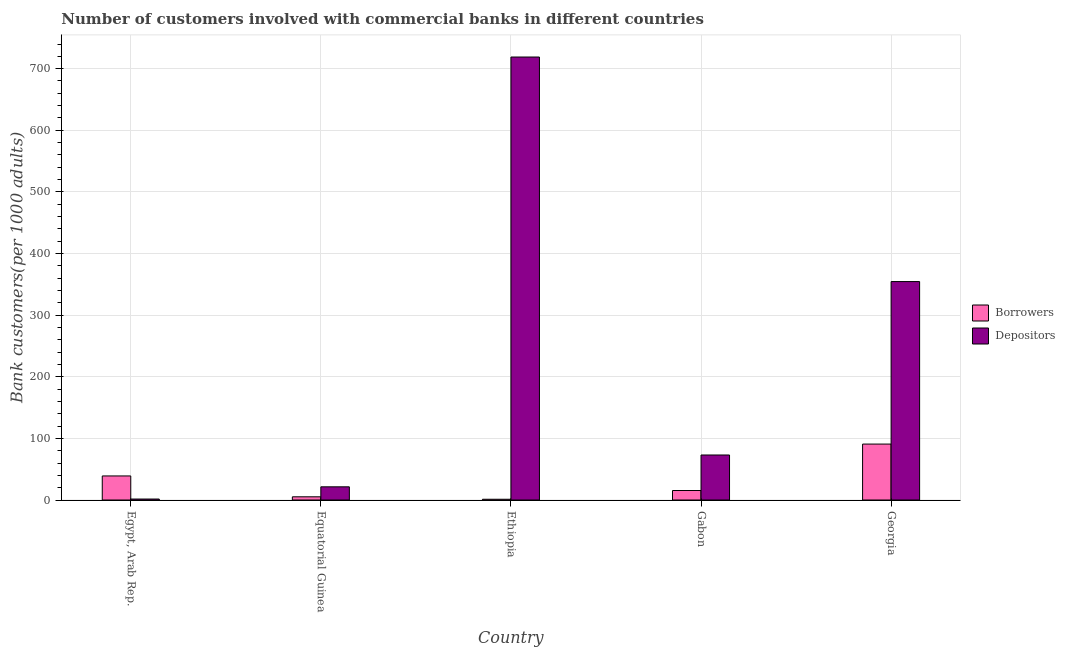How many different coloured bars are there?
Offer a very short reply. 2. How many groups of bars are there?
Your answer should be compact. 5. Are the number of bars per tick equal to the number of legend labels?
Ensure brevity in your answer.  Yes. Are the number of bars on each tick of the X-axis equal?
Make the answer very short. Yes. How many bars are there on the 3rd tick from the left?
Provide a succinct answer. 2. What is the label of the 2nd group of bars from the left?
Keep it short and to the point. Equatorial Guinea. In how many cases, is the number of bars for a given country not equal to the number of legend labels?
Your response must be concise. 0. What is the number of borrowers in Equatorial Guinea?
Offer a very short reply. 5.18. Across all countries, what is the maximum number of depositors?
Offer a very short reply. 718.87. Across all countries, what is the minimum number of depositors?
Make the answer very short. 1.56. In which country was the number of borrowers maximum?
Provide a succinct answer. Georgia. In which country was the number of borrowers minimum?
Provide a short and direct response. Ethiopia. What is the total number of borrowers in the graph?
Ensure brevity in your answer.  151.61. What is the difference between the number of borrowers in Equatorial Guinea and that in Ethiopia?
Make the answer very short. 3.97. What is the difference between the number of depositors in Georgia and the number of borrowers in Egypt, Arab Rep.?
Ensure brevity in your answer.  315.41. What is the average number of depositors per country?
Offer a terse response. 233.86. What is the difference between the number of depositors and number of borrowers in Georgia?
Your answer should be very brief. 263.68. What is the ratio of the number of borrowers in Equatorial Guinea to that in Gabon?
Your answer should be compact. 0.34. Is the number of depositors in Ethiopia less than that in Gabon?
Your answer should be very brief. No. What is the difference between the highest and the second highest number of depositors?
Offer a very short reply. 364.4. What is the difference between the highest and the lowest number of borrowers?
Keep it short and to the point. 89.57. In how many countries, is the number of depositors greater than the average number of depositors taken over all countries?
Provide a short and direct response. 2. What does the 1st bar from the left in Gabon represents?
Keep it short and to the point. Borrowers. What does the 2nd bar from the right in Georgia represents?
Give a very brief answer. Borrowers. How many countries are there in the graph?
Keep it short and to the point. 5. Does the graph contain grids?
Your response must be concise. Yes. Where does the legend appear in the graph?
Your answer should be very brief. Center right. How many legend labels are there?
Offer a terse response. 2. How are the legend labels stacked?
Your answer should be very brief. Vertical. What is the title of the graph?
Give a very brief answer. Number of customers involved with commercial banks in different countries. What is the label or title of the Y-axis?
Offer a very short reply. Bank customers(per 1000 adults). What is the Bank customers(per 1000 adults) in Borrowers in Egypt, Arab Rep.?
Keep it short and to the point. 39.05. What is the Bank customers(per 1000 adults) in Depositors in Egypt, Arab Rep.?
Offer a terse response. 1.56. What is the Bank customers(per 1000 adults) of Borrowers in Equatorial Guinea?
Keep it short and to the point. 5.18. What is the Bank customers(per 1000 adults) of Depositors in Equatorial Guinea?
Give a very brief answer. 21.4. What is the Bank customers(per 1000 adults) of Borrowers in Ethiopia?
Make the answer very short. 1.21. What is the Bank customers(per 1000 adults) of Depositors in Ethiopia?
Keep it short and to the point. 718.87. What is the Bank customers(per 1000 adults) in Borrowers in Gabon?
Offer a terse response. 15.4. What is the Bank customers(per 1000 adults) of Depositors in Gabon?
Your response must be concise. 73.03. What is the Bank customers(per 1000 adults) of Borrowers in Georgia?
Your answer should be very brief. 90.78. What is the Bank customers(per 1000 adults) in Depositors in Georgia?
Offer a very short reply. 354.46. Across all countries, what is the maximum Bank customers(per 1000 adults) of Borrowers?
Keep it short and to the point. 90.78. Across all countries, what is the maximum Bank customers(per 1000 adults) in Depositors?
Make the answer very short. 718.87. Across all countries, what is the minimum Bank customers(per 1000 adults) in Borrowers?
Provide a succinct answer. 1.21. Across all countries, what is the minimum Bank customers(per 1000 adults) of Depositors?
Make the answer very short. 1.56. What is the total Bank customers(per 1000 adults) in Borrowers in the graph?
Your answer should be compact. 151.61. What is the total Bank customers(per 1000 adults) of Depositors in the graph?
Ensure brevity in your answer.  1169.32. What is the difference between the Bank customers(per 1000 adults) of Borrowers in Egypt, Arab Rep. and that in Equatorial Guinea?
Your answer should be compact. 33.87. What is the difference between the Bank customers(per 1000 adults) in Depositors in Egypt, Arab Rep. and that in Equatorial Guinea?
Ensure brevity in your answer.  -19.83. What is the difference between the Bank customers(per 1000 adults) of Borrowers in Egypt, Arab Rep. and that in Ethiopia?
Offer a very short reply. 37.84. What is the difference between the Bank customers(per 1000 adults) in Depositors in Egypt, Arab Rep. and that in Ethiopia?
Ensure brevity in your answer.  -717.3. What is the difference between the Bank customers(per 1000 adults) of Borrowers in Egypt, Arab Rep. and that in Gabon?
Keep it short and to the point. 23.65. What is the difference between the Bank customers(per 1000 adults) of Depositors in Egypt, Arab Rep. and that in Gabon?
Offer a terse response. -71.47. What is the difference between the Bank customers(per 1000 adults) of Borrowers in Egypt, Arab Rep. and that in Georgia?
Your answer should be very brief. -51.73. What is the difference between the Bank customers(per 1000 adults) of Depositors in Egypt, Arab Rep. and that in Georgia?
Your response must be concise. -352.9. What is the difference between the Bank customers(per 1000 adults) in Borrowers in Equatorial Guinea and that in Ethiopia?
Make the answer very short. 3.97. What is the difference between the Bank customers(per 1000 adults) of Depositors in Equatorial Guinea and that in Ethiopia?
Your answer should be very brief. -697.47. What is the difference between the Bank customers(per 1000 adults) of Borrowers in Equatorial Guinea and that in Gabon?
Ensure brevity in your answer.  -10.22. What is the difference between the Bank customers(per 1000 adults) of Depositors in Equatorial Guinea and that in Gabon?
Give a very brief answer. -51.64. What is the difference between the Bank customers(per 1000 adults) of Borrowers in Equatorial Guinea and that in Georgia?
Offer a very short reply. -85.6. What is the difference between the Bank customers(per 1000 adults) in Depositors in Equatorial Guinea and that in Georgia?
Provide a succinct answer. -333.07. What is the difference between the Bank customers(per 1000 adults) of Borrowers in Ethiopia and that in Gabon?
Provide a succinct answer. -14.2. What is the difference between the Bank customers(per 1000 adults) of Depositors in Ethiopia and that in Gabon?
Your response must be concise. 645.83. What is the difference between the Bank customers(per 1000 adults) of Borrowers in Ethiopia and that in Georgia?
Give a very brief answer. -89.57. What is the difference between the Bank customers(per 1000 adults) of Depositors in Ethiopia and that in Georgia?
Your response must be concise. 364.4. What is the difference between the Bank customers(per 1000 adults) in Borrowers in Gabon and that in Georgia?
Ensure brevity in your answer.  -75.38. What is the difference between the Bank customers(per 1000 adults) of Depositors in Gabon and that in Georgia?
Keep it short and to the point. -281.43. What is the difference between the Bank customers(per 1000 adults) in Borrowers in Egypt, Arab Rep. and the Bank customers(per 1000 adults) in Depositors in Equatorial Guinea?
Your answer should be very brief. 17.65. What is the difference between the Bank customers(per 1000 adults) in Borrowers in Egypt, Arab Rep. and the Bank customers(per 1000 adults) in Depositors in Ethiopia?
Make the answer very short. -679.82. What is the difference between the Bank customers(per 1000 adults) in Borrowers in Egypt, Arab Rep. and the Bank customers(per 1000 adults) in Depositors in Gabon?
Keep it short and to the point. -33.98. What is the difference between the Bank customers(per 1000 adults) of Borrowers in Egypt, Arab Rep. and the Bank customers(per 1000 adults) of Depositors in Georgia?
Your answer should be very brief. -315.41. What is the difference between the Bank customers(per 1000 adults) in Borrowers in Equatorial Guinea and the Bank customers(per 1000 adults) in Depositors in Ethiopia?
Give a very brief answer. -713.69. What is the difference between the Bank customers(per 1000 adults) of Borrowers in Equatorial Guinea and the Bank customers(per 1000 adults) of Depositors in Gabon?
Make the answer very short. -67.85. What is the difference between the Bank customers(per 1000 adults) in Borrowers in Equatorial Guinea and the Bank customers(per 1000 adults) in Depositors in Georgia?
Keep it short and to the point. -349.29. What is the difference between the Bank customers(per 1000 adults) of Borrowers in Ethiopia and the Bank customers(per 1000 adults) of Depositors in Gabon?
Offer a terse response. -71.83. What is the difference between the Bank customers(per 1000 adults) of Borrowers in Ethiopia and the Bank customers(per 1000 adults) of Depositors in Georgia?
Keep it short and to the point. -353.26. What is the difference between the Bank customers(per 1000 adults) in Borrowers in Gabon and the Bank customers(per 1000 adults) in Depositors in Georgia?
Make the answer very short. -339.06. What is the average Bank customers(per 1000 adults) in Borrowers per country?
Offer a terse response. 30.32. What is the average Bank customers(per 1000 adults) in Depositors per country?
Your answer should be compact. 233.86. What is the difference between the Bank customers(per 1000 adults) in Borrowers and Bank customers(per 1000 adults) in Depositors in Egypt, Arab Rep.?
Your answer should be compact. 37.49. What is the difference between the Bank customers(per 1000 adults) of Borrowers and Bank customers(per 1000 adults) of Depositors in Equatorial Guinea?
Your response must be concise. -16.22. What is the difference between the Bank customers(per 1000 adults) of Borrowers and Bank customers(per 1000 adults) of Depositors in Ethiopia?
Provide a succinct answer. -717.66. What is the difference between the Bank customers(per 1000 adults) of Borrowers and Bank customers(per 1000 adults) of Depositors in Gabon?
Your answer should be compact. -57.63. What is the difference between the Bank customers(per 1000 adults) of Borrowers and Bank customers(per 1000 adults) of Depositors in Georgia?
Give a very brief answer. -263.69. What is the ratio of the Bank customers(per 1000 adults) of Borrowers in Egypt, Arab Rep. to that in Equatorial Guinea?
Provide a succinct answer. 7.54. What is the ratio of the Bank customers(per 1000 adults) of Depositors in Egypt, Arab Rep. to that in Equatorial Guinea?
Offer a very short reply. 0.07. What is the ratio of the Bank customers(per 1000 adults) in Borrowers in Egypt, Arab Rep. to that in Ethiopia?
Offer a very short reply. 32.39. What is the ratio of the Bank customers(per 1000 adults) in Depositors in Egypt, Arab Rep. to that in Ethiopia?
Ensure brevity in your answer.  0. What is the ratio of the Bank customers(per 1000 adults) of Borrowers in Egypt, Arab Rep. to that in Gabon?
Your response must be concise. 2.54. What is the ratio of the Bank customers(per 1000 adults) in Depositors in Egypt, Arab Rep. to that in Gabon?
Your answer should be compact. 0.02. What is the ratio of the Bank customers(per 1000 adults) of Borrowers in Egypt, Arab Rep. to that in Georgia?
Ensure brevity in your answer.  0.43. What is the ratio of the Bank customers(per 1000 adults) in Depositors in Egypt, Arab Rep. to that in Georgia?
Your answer should be compact. 0. What is the ratio of the Bank customers(per 1000 adults) of Borrowers in Equatorial Guinea to that in Ethiopia?
Make the answer very short. 4.29. What is the ratio of the Bank customers(per 1000 adults) in Depositors in Equatorial Guinea to that in Ethiopia?
Give a very brief answer. 0.03. What is the ratio of the Bank customers(per 1000 adults) in Borrowers in Equatorial Guinea to that in Gabon?
Make the answer very short. 0.34. What is the ratio of the Bank customers(per 1000 adults) in Depositors in Equatorial Guinea to that in Gabon?
Offer a very short reply. 0.29. What is the ratio of the Bank customers(per 1000 adults) of Borrowers in Equatorial Guinea to that in Georgia?
Offer a terse response. 0.06. What is the ratio of the Bank customers(per 1000 adults) in Depositors in Equatorial Guinea to that in Georgia?
Offer a very short reply. 0.06. What is the ratio of the Bank customers(per 1000 adults) of Borrowers in Ethiopia to that in Gabon?
Your answer should be compact. 0.08. What is the ratio of the Bank customers(per 1000 adults) of Depositors in Ethiopia to that in Gabon?
Provide a succinct answer. 9.84. What is the ratio of the Bank customers(per 1000 adults) in Borrowers in Ethiopia to that in Georgia?
Give a very brief answer. 0.01. What is the ratio of the Bank customers(per 1000 adults) in Depositors in Ethiopia to that in Georgia?
Your answer should be compact. 2.03. What is the ratio of the Bank customers(per 1000 adults) of Borrowers in Gabon to that in Georgia?
Your answer should be very brief. 0.17. What is the ratio of the Bank customers(per 1000 adults) of Depositors in Gabon to that in Georgia?
Your response must be concise. 0.21. What is the difference between the highest and the second highest Bank customers(per 1000 adults) in Borrowers?
Make the answer very short. 51.73. What is the difference between the highest and the second highest Bank customers(per 1000 adults) in Depositors?
Provide a short and direct response. 364.4. What is the difference between the highest and the lowest Bank customers(per 1000 adults) in Borrowers?
Ensure brevity in your answer.  89.57. What is the difference between the highest and the lowest Bank customers(per 1000 adults) of Depositors?
Give a very brief answer. 717.3. 